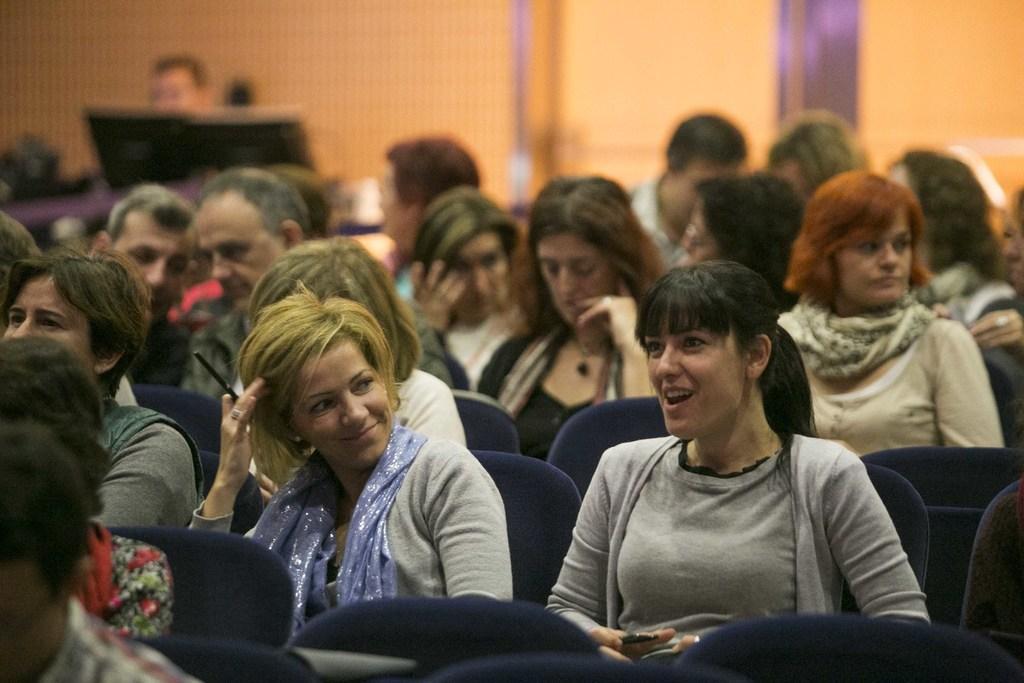In one or two sentences, can you explain what this image depicts? A beautiful woman is sitting on the chair, she wore t-shirt and smiling and there are other people sitting on this chairs. 